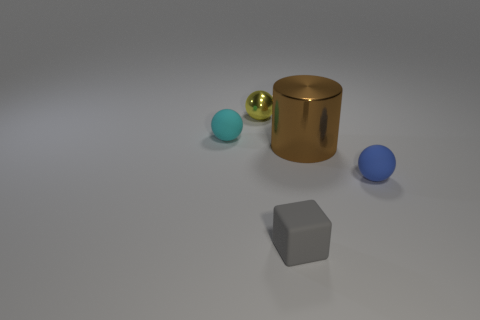Are there more metal balls that are left of the tiny yellow sphere than yellow balls? no 